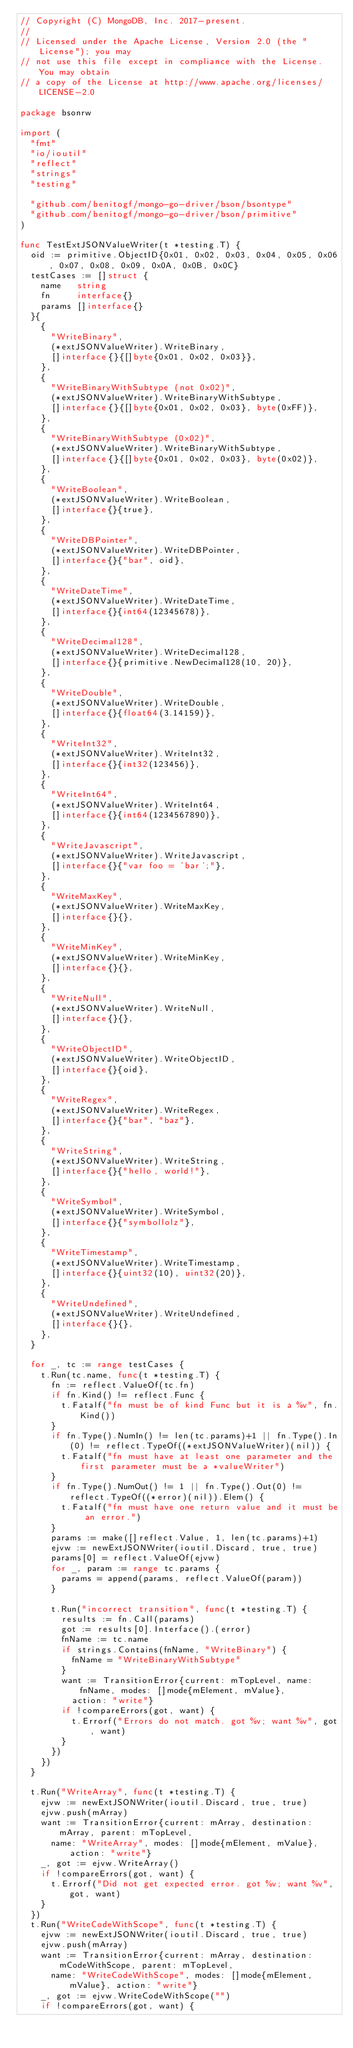Convert code to text. <code><loc_0><loc_0><loc_500><loc_500><_Go_>// Copyright (C) MongoDB, Inc. 2017-present.
//
// Licensed under the Apache License, Version 2.0 (the "License"); you may
// not use this file except in compliance with the License. You may obtain
// a copy of the License at http://www.apache.org/licenses/LICENSE-2.0

package bsonrw

import (
	"fmt"
	"io/ioutil"
	"reflect"
	"strings"
	"testing"

	"github.com/benitogf/mongo-go-driver/bson/bsontype"
	"github.com/benitogf/mongo-go-driver/bson/primitive"
)

func TestExtJSONValueWriter(t *testing.T) {
	oid := primitive.ObjectID{0x01, 0x02, 0x03, 0x04, 0x05, 0x06, 0x07, 0x08, 0x09, 0x0A, 0x0B, 0x0C}
	testCases := []struct {
		name   string
		fn     interface{}
		params []interface{}
	}{
		{
			"WriteBinary",
			(*extJSONValueWriter).WriteBinary,
			[]interface{}{[]byte{0x01, 0x02, 0x03}},
		},
		{
			"WriteBinaryWithSubtype (not 0x02)",
			(*extJSONValueWriter).WriteBinaryWithSubtype,
			[]interface{}{[]byte{0x01, 0x02, 0x03}, byte(0xFF)},
		},
		{
			"WriteBinaryWithSubtype (0x02)",
			(*extJSONValueWriter).WriteBinaryWithSubtype,
			[]interface{}{[]byte{0x01, 0x02, 0x03}, byte(0x02)},
		},
		{
			"WriteBoolean",
			(*extJSONValueWriter).WriteBoolean,
			[]interface{}{true},
		},
		{
			"WriteDBPointer",
			(*extJSONValueWriter).WriteDBPointer,
			[]interface{}{"bar", oid},
		},
		{
			"WriteDateTime",
			(*extJSONValueWriter).WriteDateTime,
			[]interface{}{int64(12345678)},
		},
		{
			"WriteDecimal128",
			(*extJSONValueWriter).WriteDecimal128,
			[]interface{}{primitive.NewDecimal128(10, 20)},
		},
		{
			"WriteDouble",
			(*extJSONValueWriter).WriteDouble,
			[]interface{}{float64(3.14159)},
		},
		{
			"WriteInt32",
			(*extJSONValueWriter).WriteInt32,
			[]interface{}{int32(123456)},
		},
		{
			"WriteInt64",
			(*extJSONValueWriter).WriteInt64,
			[]interface{}{int64(1234567890)},
		},
		{
			"WriteJavascript",
			(*extJSONValueWriter).WriteJavascript,
			[]interface{}{"var foo = 'bar';"},
		},
		{
			"WriteMaxKey",
			(*extJSONValueWriter).WriteMaxKey,
			[]interface{}{},
		},
		{
			"WriteMinKey",
			(*extJSONValueWriter).WriteMinKey,
			[]interface{}{},
		},
		{
			"WriteNull",
			(*extJSONValueWriter).WriteNull,
			[]interface{}{},
		},
		{
			"WriteObjectID",
			(*extJSONValueWriter).WriteObjectID,
			[]interface{}{oid},
		},
		{
			"WriteRegex",
			(*extJSONValueWriter).WriteRegex,
			[]interface{}{"bar", "baz"},
		},
		{
			"WriteString",
			(*extJSONValueWriter).WriteString,
			[]interface{}{"hello, world!"},
		},
		{
			"WriteSymbol",
			(*extJSONValueWriter).WriteSymbol,
			[]interface{}{"symbollolz"},
		},
		{
			"WriteTimestamp",
			(*extJSONValueWriter).WriteTimestamp,
			[]interface{}{uint32(10), uint32(20)},
		},
		{
			"WriteUndefined",
			(*extJSONValueWriter).WriteUndefined,
			[]interface{}{},
		},
	}

	for _, tc := range testCases {
		t.Run(tc.name, func(t *testing.T) {
			fn := reflect.ValueOf(tc.fn)
			if fn.Kind() != reflect.Func {
				t.Fatalf("fn must be of kind Func but it is a %v", fn.Kind())
			}
			if fn.Type().NumIn() != len(tc.params)+1 || fn.Type().In(0) != reflect.TypeOf((*extJSONValueWriter)(nil)) {
				t.Fatalf("fn must have at least one parameter and the first parameter must be a *valueWriter")
			}
			if fn.Type().NumOut() != 1 || fn.Type().Out(0) != reflect.TypeOf((*error)(nil)).Elem() {
				t.Fatalf("fn must have one return value and it must be an error.")
			}
			params := make([]reflect.Value, 1, len(tc.params)+1)
			ejvw := newExtJSONWriter(ioutil.Discard, true, true)
			params[0] = reflect.ValueOf(ejvw)
			for _, param := range tc.params {
				params = append(params, reflect.ValueOf(param))
			}

			t.Run("incorrect transition", func(t *testing.T) {
				results := fn.Call(params)
				got := results[0].Interface().(error)
				fnName := tc.name
				if strings.Contains(fnName, "WriteBinary") {
					fnName = "WriteBinaryWithSubtype"
				}
				want := TransitionError{current: mTopLevel, name: fnName, modes: []mode{mElement, mValue},
					action: "write"}
				if !compareErrors(got, want) {
					t.Errorf("Errors do not match. got %v; want %v", got, want)
				}
			})
		})
	}

	t.Run("WriteArray", func(t *testing.T) {
		ejvw := newExtJSONWriter(ioutil.Discard, true, true)
		ejvw.push(mArray)
		want := TransitionError{current: mArray, destination: mArray, parent: mTopLevel,
			name: "WriteArray", modes: []mode{mElement, mValue}, action: "write"}
		_, got := ejvw.WriteArray()
		if !compareErrors(got, want) {
			t.Errorf("Did not get expected error. got %v; want %v", got, want)
		}
	})
	t.Run("WriteCodeWithScope", func(t *testing.T) {
		ejvw := newExtJSONWriter(ioutil.Discard, true, true)
		ejvw.push(mArray)
		want := TransitionError{current: mArray, destination: mCodeWithScope, parent: mTopLevel,
			name: "WriteCodeWithScope", modes: []mode{mElement, mValue}, action: "write"}
		_, got := ejvw.WriteCodeWithScope("")
		if !compareErrors(got, want) {</code> 